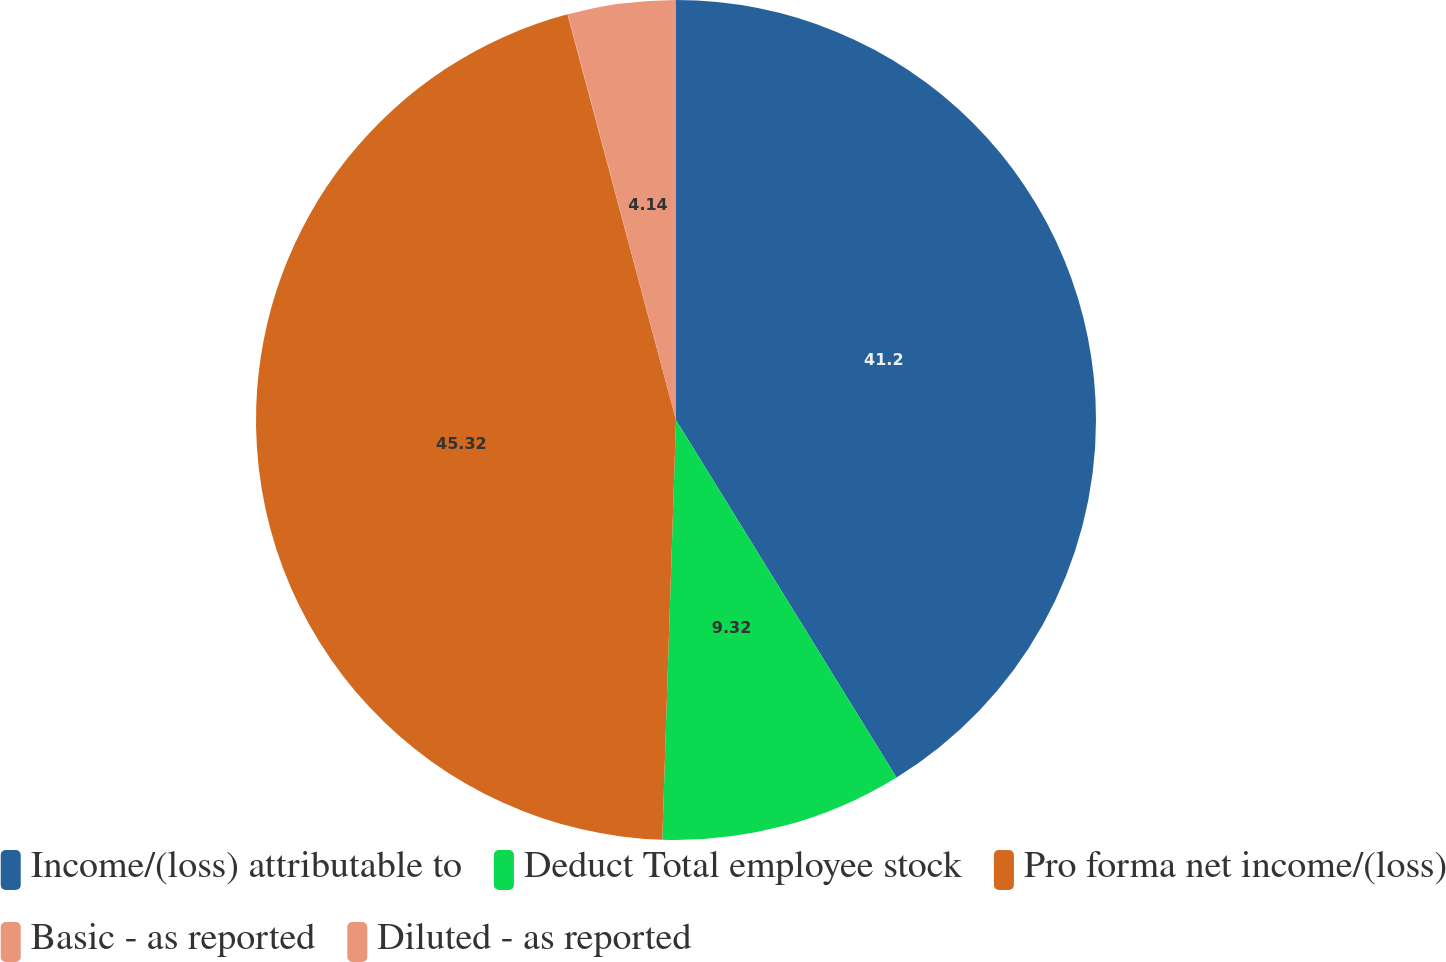Convert chart to OTSL. <chart><loc_0><loc_0><loc_500><loc_500><pie_chart><fcel>Income/(loss) attributable to<fcel>Deduct Total employee stock<fcel>Pro forma net income/(loss)<fcel>Basic - as reported<fcel>Diluted - as reported<nl><fcel>41.2%<fcel>9.32%<fcel>45.32%<fcel>0.02%<fcel>4.14%<nl></chart> 